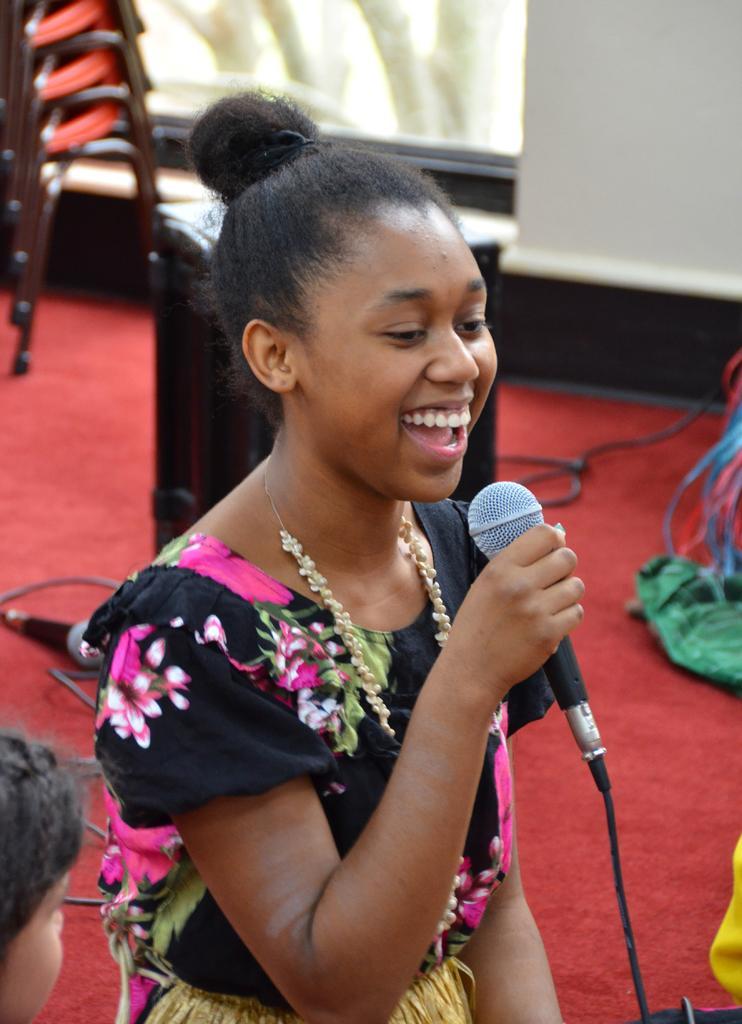Can you describe this image briefly? In the image we can see there is a woman who is holding mic in her hand. 